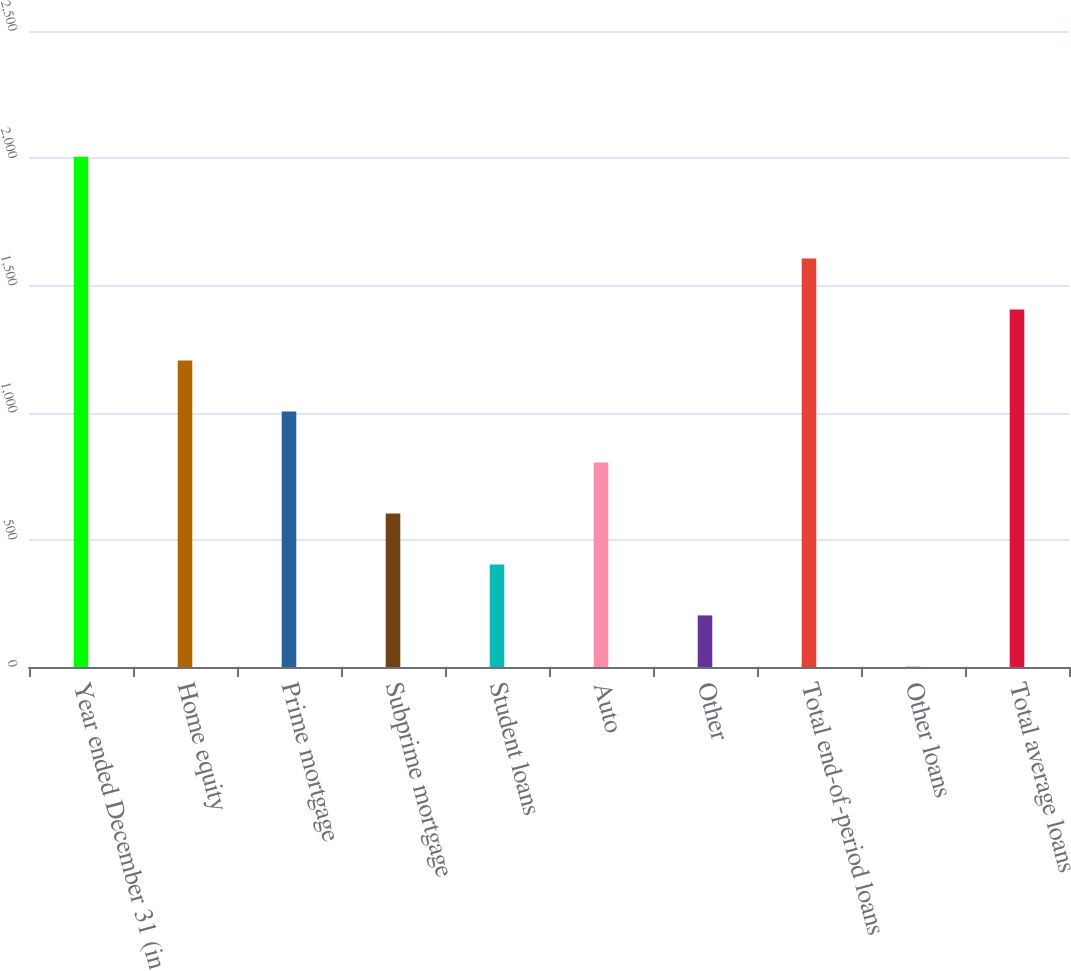<chart> <loc_0><loc_0><loc_500><loc_500><bar_chart><fcel>Year ended December 31 (in<fcel>Home equity<fcel>Prime mortgage<fcel>Subprime mortgage<fcel>Student loans<fcel>Auto<fcel>Other<fcel>Total end-of-period loans<fcel>Other loans<fcel>Total average loans<nl><fcel>2006<fcel>1204.56<fcel>1004.2<fcel>603.48<fcel>403.12<fcel>803.84<fcel>202.76<fcel>1605.28<fcel>2.4<fcel>1404.92<nl></chart> 